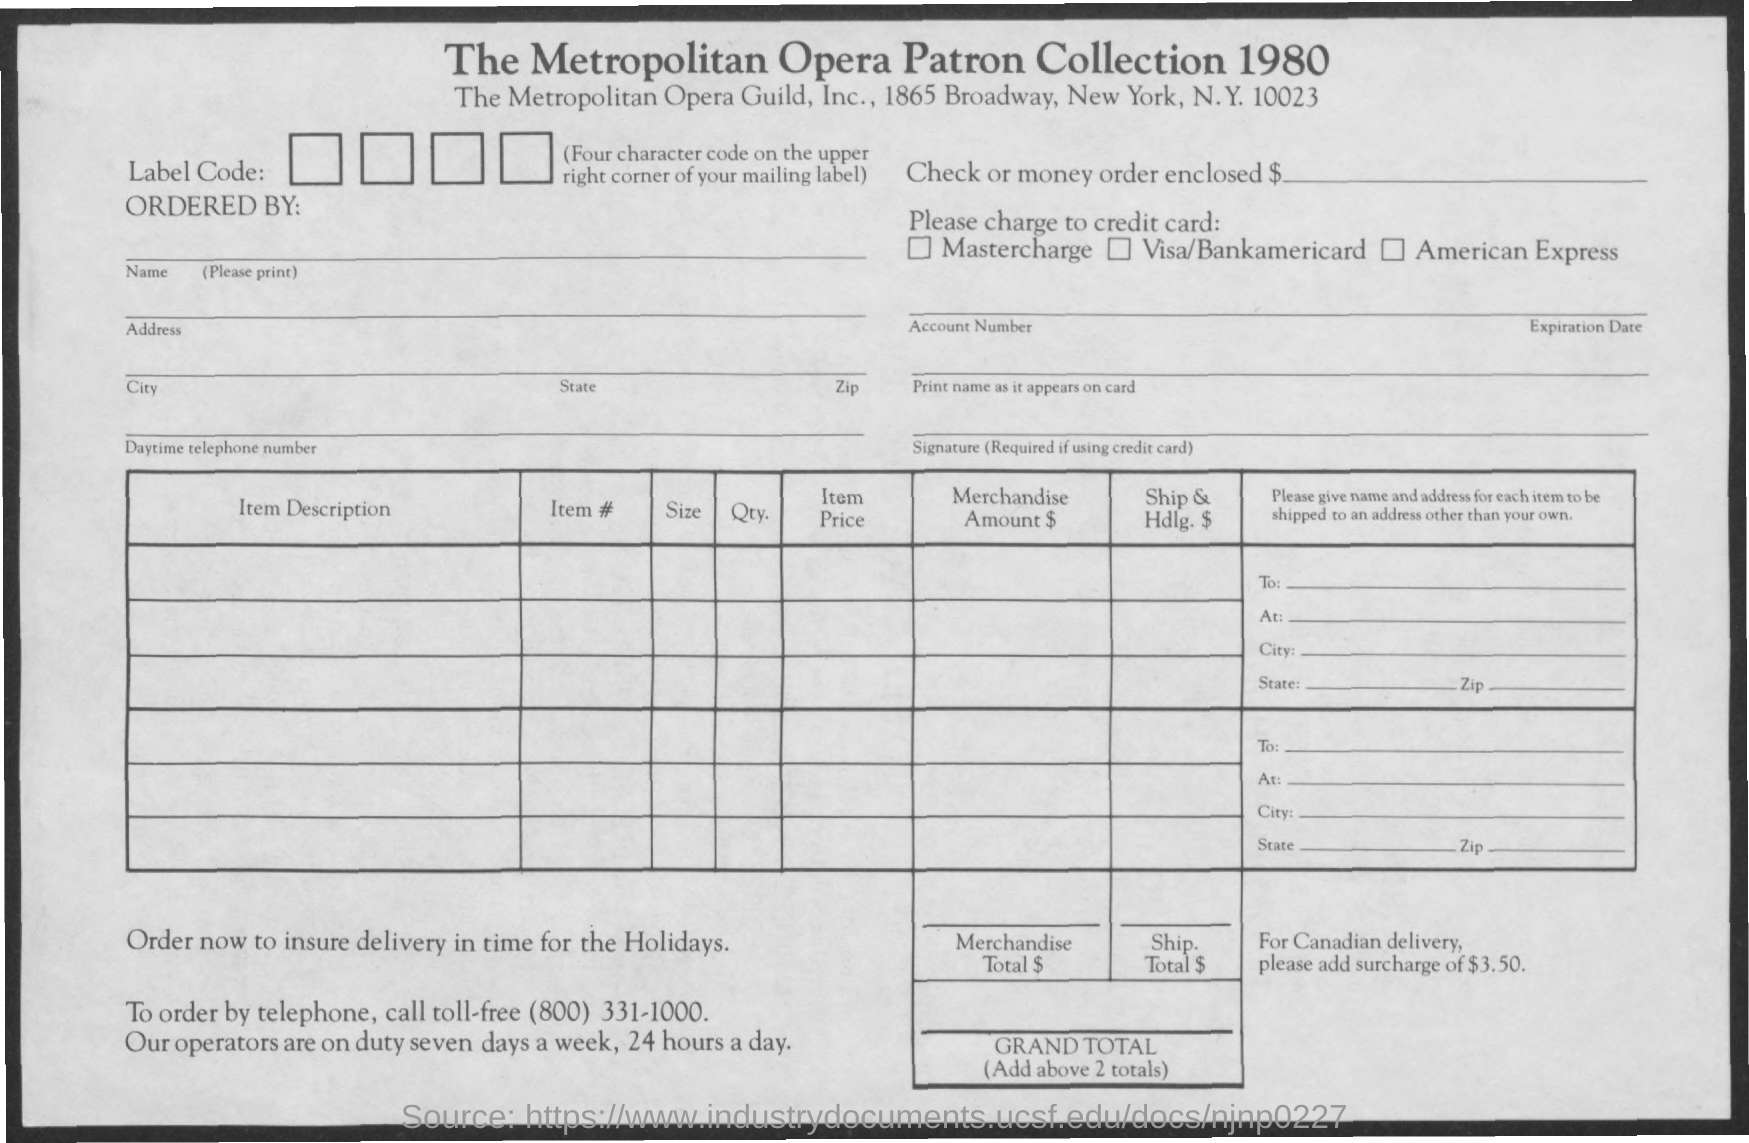Highlight a few significant elements in this photo. The city mentioned is New York. 